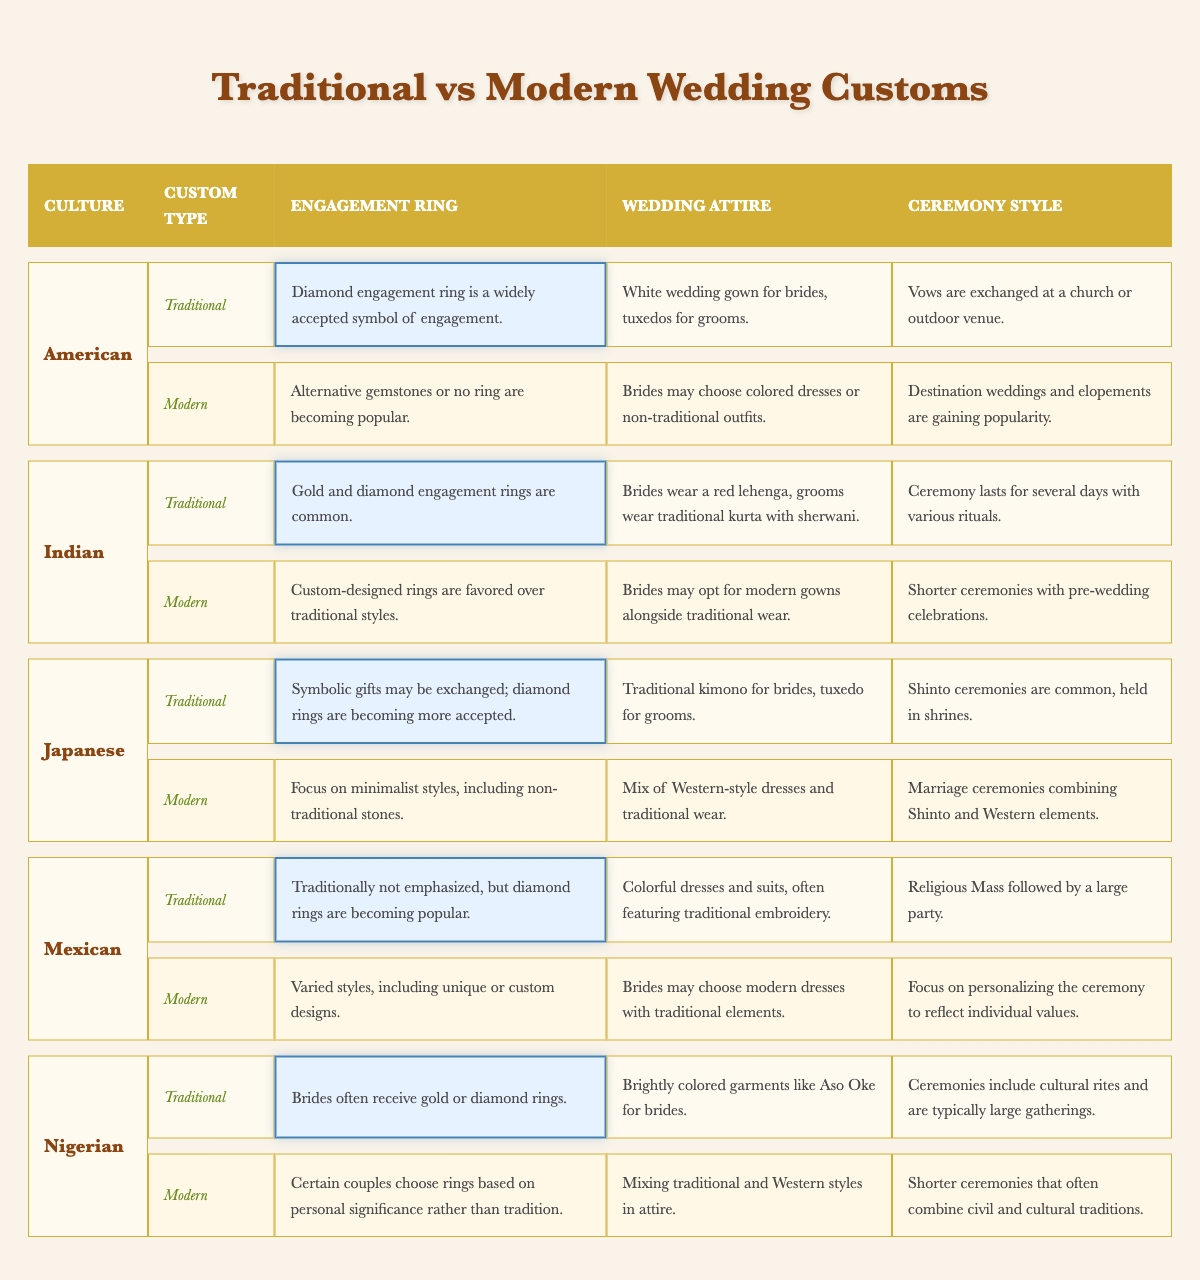What type of engagement ring is most prevalent in traditional American weddings? The table indicates that a diamond engagement ring is a widely accepted symbol of engagement in traditional American weddings.
Answer: Diamond engagement ring In Japanese traditional weddings, what is the common attire for brides? According to the table, traditional brides in Japan wear a kimono during the wedding ceremony.
Answer: Traditional kimono Do modern Mexican weddings emphasize engagement rings? The table states that traditionally engagement rings are not emphasized in Mexican weddings, but diamond rings are becoming popular, suggesting a shift in modern customs.
Answer: No Which culture has the longest ceremony style according to traditional customs? The traditional customs of Indian weddings include ceremonies that last several days with various rituals, making it the longest compared to the others listed.
Answer: Indian What is a common change in wedding attire among modern Indian weddings? Modern Indian weddings see brides opting for modern gowns alongside traditional wear, indicating a blending of styles.
Answer: Modern gowns How do modern Nigerian couples choose their engagement rings compared to traditional customs? Traditional Nigerian customs often involve gold or diamond rings. However, modern couples may choose rings based on personal significance, stepping away from traditional preferences.
Answer: Based on personal significance What is the primary focus of modern ceremony styles in American weddings? The table states that modern American weddings are gaining popularity for destination weddings and elopements, indicating a shift towards more personalized experiences.
Answer: Destination weddings and elopements In comparing engagement ring customs, which culture has shown a trend toward custom-designed rings in modern weddings? The table notes that modern Indian couples favor custom-designed rings instead of traditional styles, highlighting a contemporary trend.
Answer: Indian Which culture maintains a distinctive color for bridal attire in traditional ceremonies? The table states that in traditional Indian weddings, brides wear red lehengas, which is a distinctive color associated with their customs.
Answer: Red lehenga Which culture combines Shinto and Western elements in modern wedding ceremonies? According to the table, modern Japanese weddings incorporate a mix of Shinto and Western elements, highlighting a unique blend of traditions.
Answer: Japanese What is the trend in engagement rings for American modern weddings? The modern trend in American weddings shows an increase in the popularity of alternative gemstones or opting for no engagement ring at all.
Answer: Alternative gemstones or no ring 